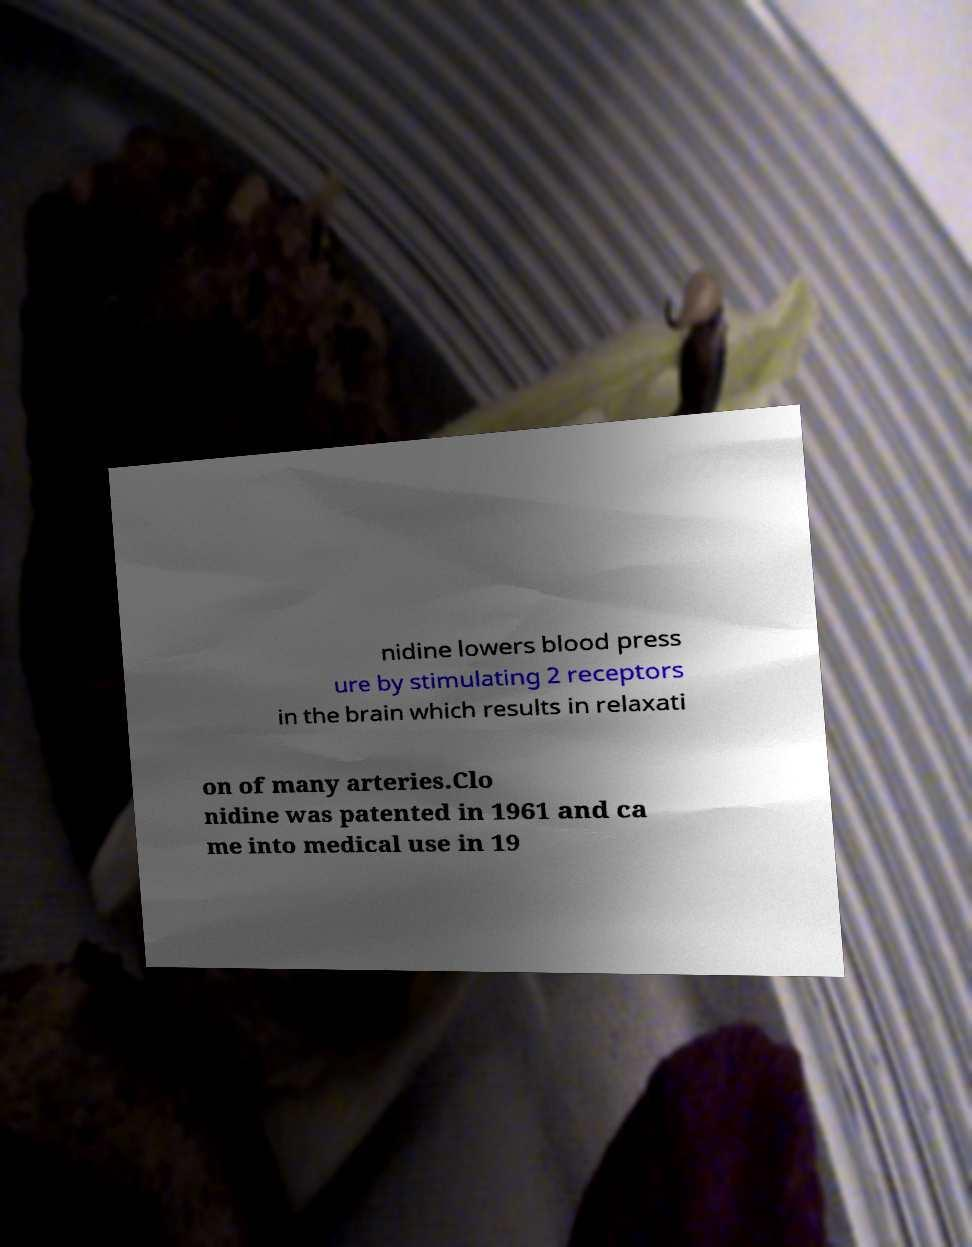What messages or text are displayed in this image? I need them in a readable, typed format. nidine lowers blood press ure by stimulating 2 receptors in the brain which results in relaxati on of many arteries.Clo nidine was patented in 1961 and ca me into medical use in 19 